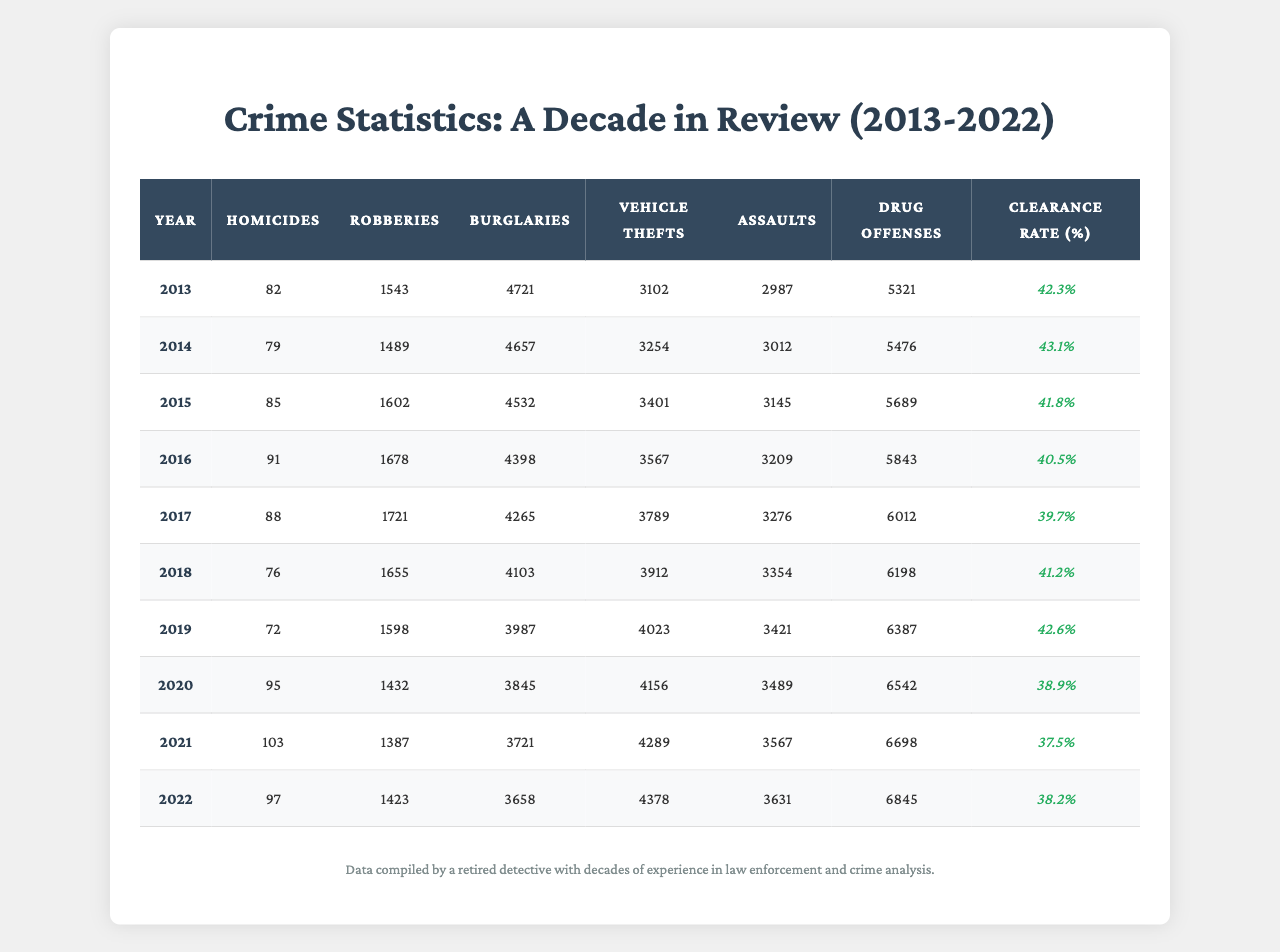What was the highest number of homicides recorded in a year? The data shows the number of homicides for each year. Looking through the "Homicides" column, the highest count is 103 in 2021.
Answer: 103 Which year had the lowest number of robberies? By examining the "Robberies" column, we see the lowest count is 1387 in 2021, which is lower than all other years listed.
Answer: 1387 How many vehicle thefts occurred in 2015? The "Vehicle Thefts" column indicates that there were 3401 vehicle thefts in the year 2015, as stated in the respective row.
Answer: 3401 What was the clearance rate in 2016? The clearance rate for the year 2016 can be found in the last column, which indicates a clearance rate of 40.5% for that year.
Answer: 40.5% What is the average number of assaults over the decade? To find the average of assaults, add together the assault counts from each year and then divide by 10 (the number of years). The total is (2987 + 3012 + 3145 + 3209 + 3276 + 3354 + 3421 + 3489 + 3567 + 3631) = 31997. Dividing by 10 gives 3199.7.
Answer: 3199.7 Was the number of drug offenses higher in 2022 than in 2014? In 2022, the number of drug offenses is 6845, while in 2014 it was 5476. Since 6845 is greater than 5476, the statement is true.
Answer: Yes In which year did the city experience the highest number of burglaries, and how many were reported? Looking at the "Burglaries" column, the highest number is found in 2013 with 4721 burglaries.
Answer: 4721, in 2013 What was the trend in vehicle thefts from 2013 to 2022? By examining the "Vehicle Thefts" column, vehicle thefts increased from 3102 in 2013 to 4378 in 2022. This indicates a rising trend over the decade.
Answer: Increasing What was the difference in the number of homicides between 2013 and 2022? The number of homicides in 2013 was 82, and in 2022 it was 97. The difference is calculated as 97 - 82 = 15.
Answer: 15 How many more drug offenses were there in 2021 compared to 2018? In 2021, there were 6698 drug offenses and in 2018, there were 6198. The difference is 6698 - 6198 = 500 more offenses in 2021.
Answer: 500 